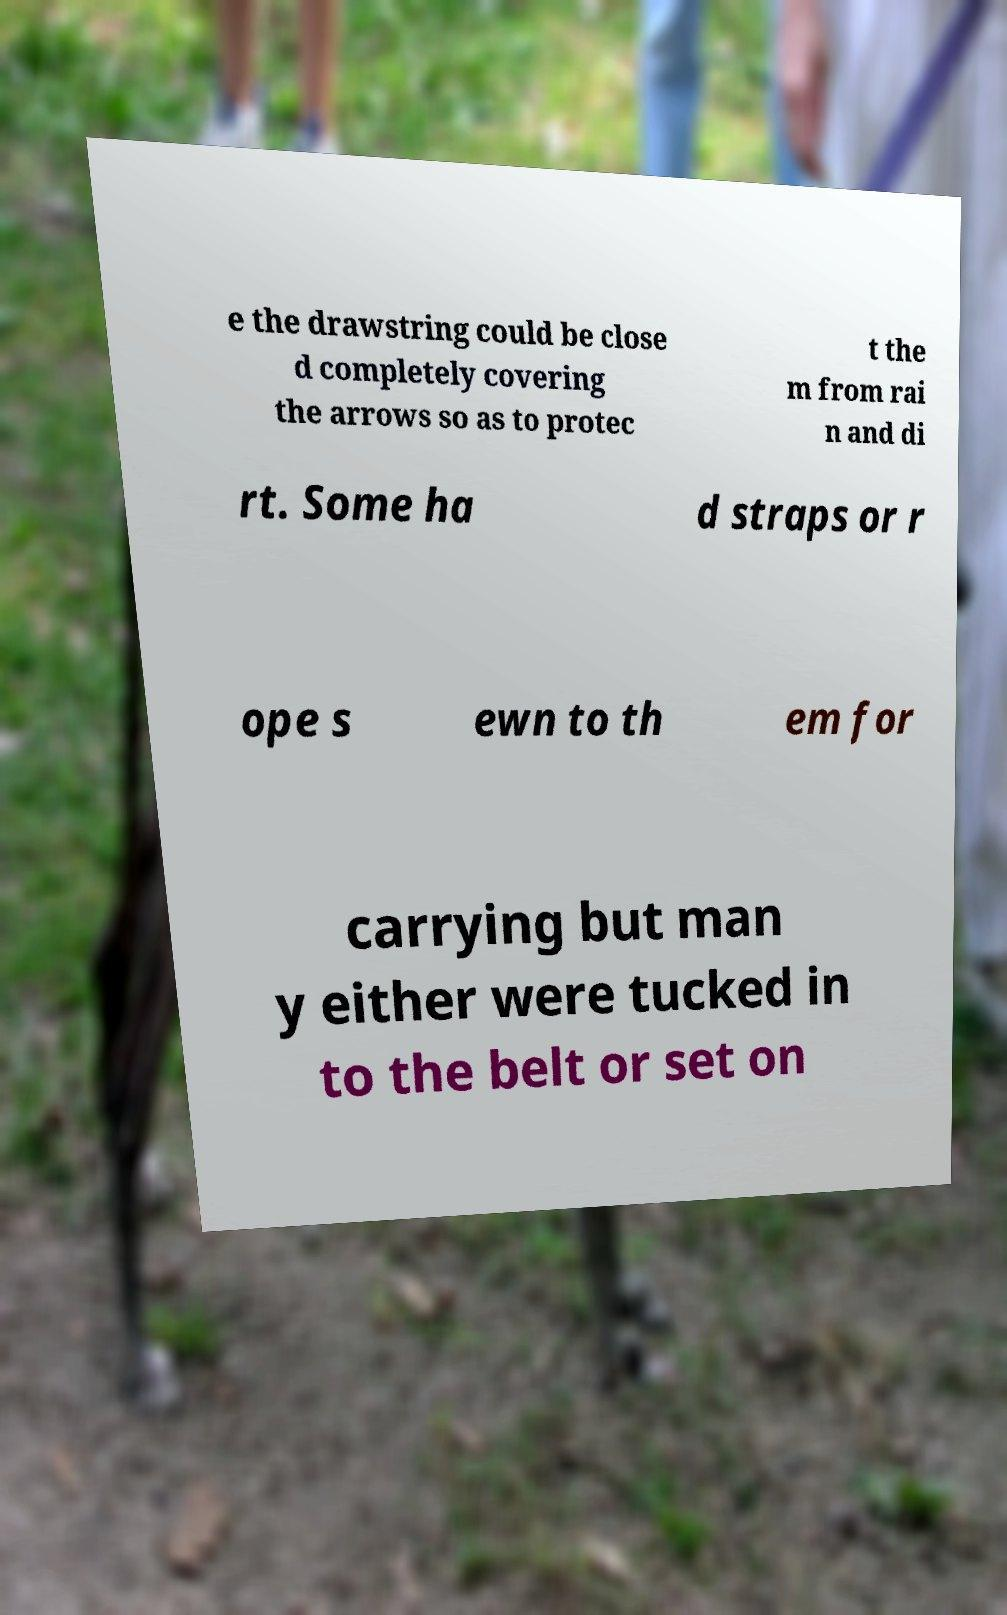Can you accurately transcribe the text from the provided image for me? e the drawstring could be close d completely covering the arrows so as to protec t the m from rai n and di rt. Some ha d straps or r ope s ewn to th em for carrying but man y either were tucked in to the belt or set on 